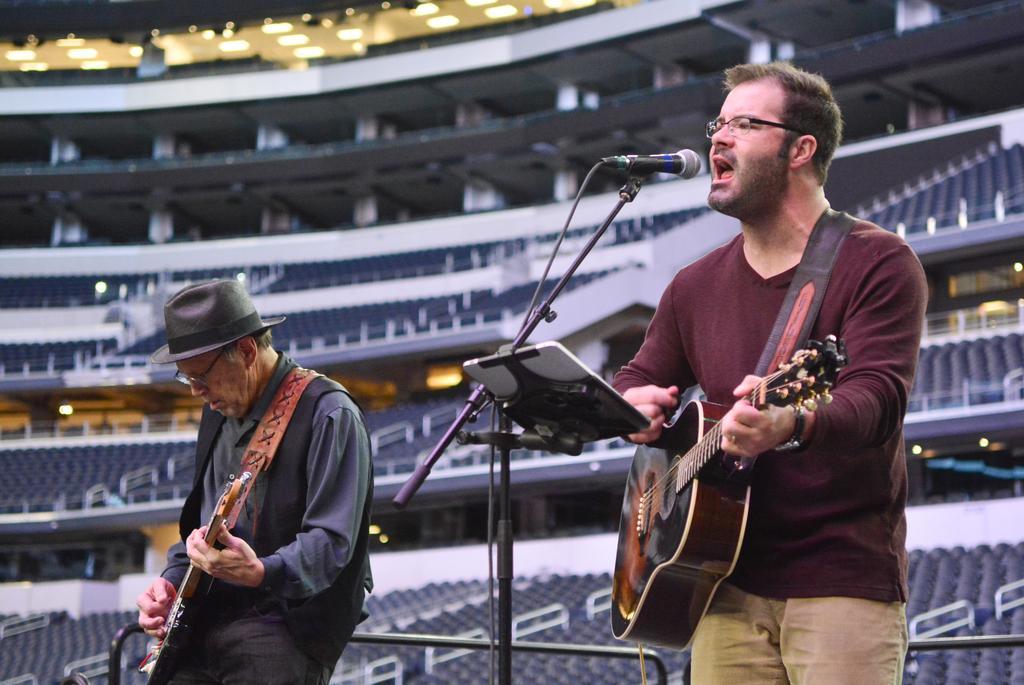How many people are in the image? There are two persons in the image. What are the persons doing in the image? Both persons are playing guitar, and one person is standing and singing. What equipment is present in the image for amplifying the singer's voice? There is a microphone with a stand in the image. What might the person with the notepad be using it for? The person with the notepad might be using it for writing lyrics or song ideas. What type of venue is suggested by the setting in the image? The setting appears to be a stadium, which suggests a large audience. What color is the picture of the middle in the image? There is no picture of the middle in the image; it features two persons playing guitar and singing. What are the hopes of the person holding the notepad in the image? We cannot determine the hopes of the person holding the notepad in the image based on the information provided. 